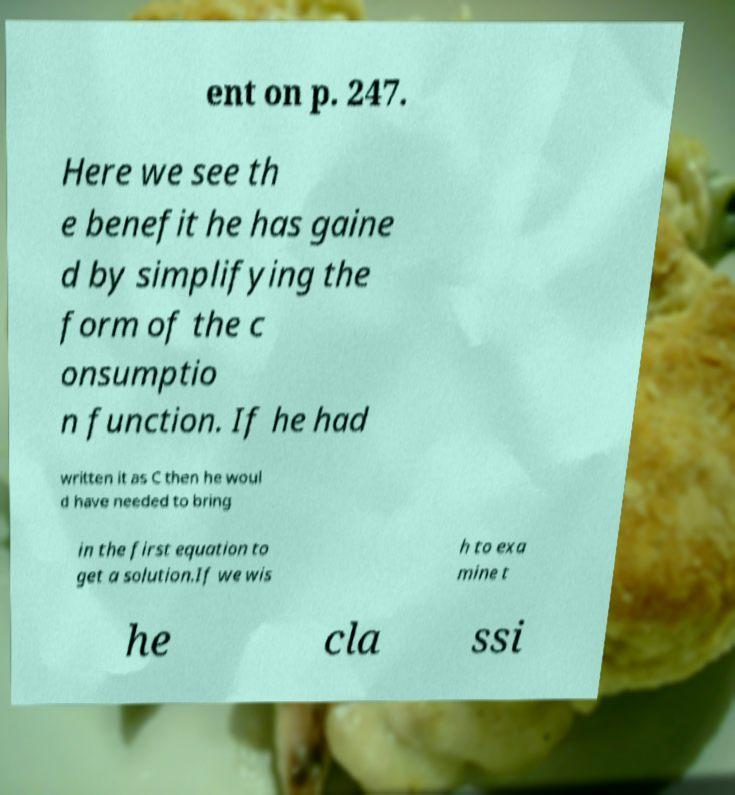I need the written content from this picture converted into text. Can you do that? ent on p. 247. Here we see th e benefit he has gaine d by simplifying the form of the c onsumptio n function. If he had written it as C then he woul d have needed to bring in the first equation to get a solution.If we wis h to exa mine t he cla ssi 